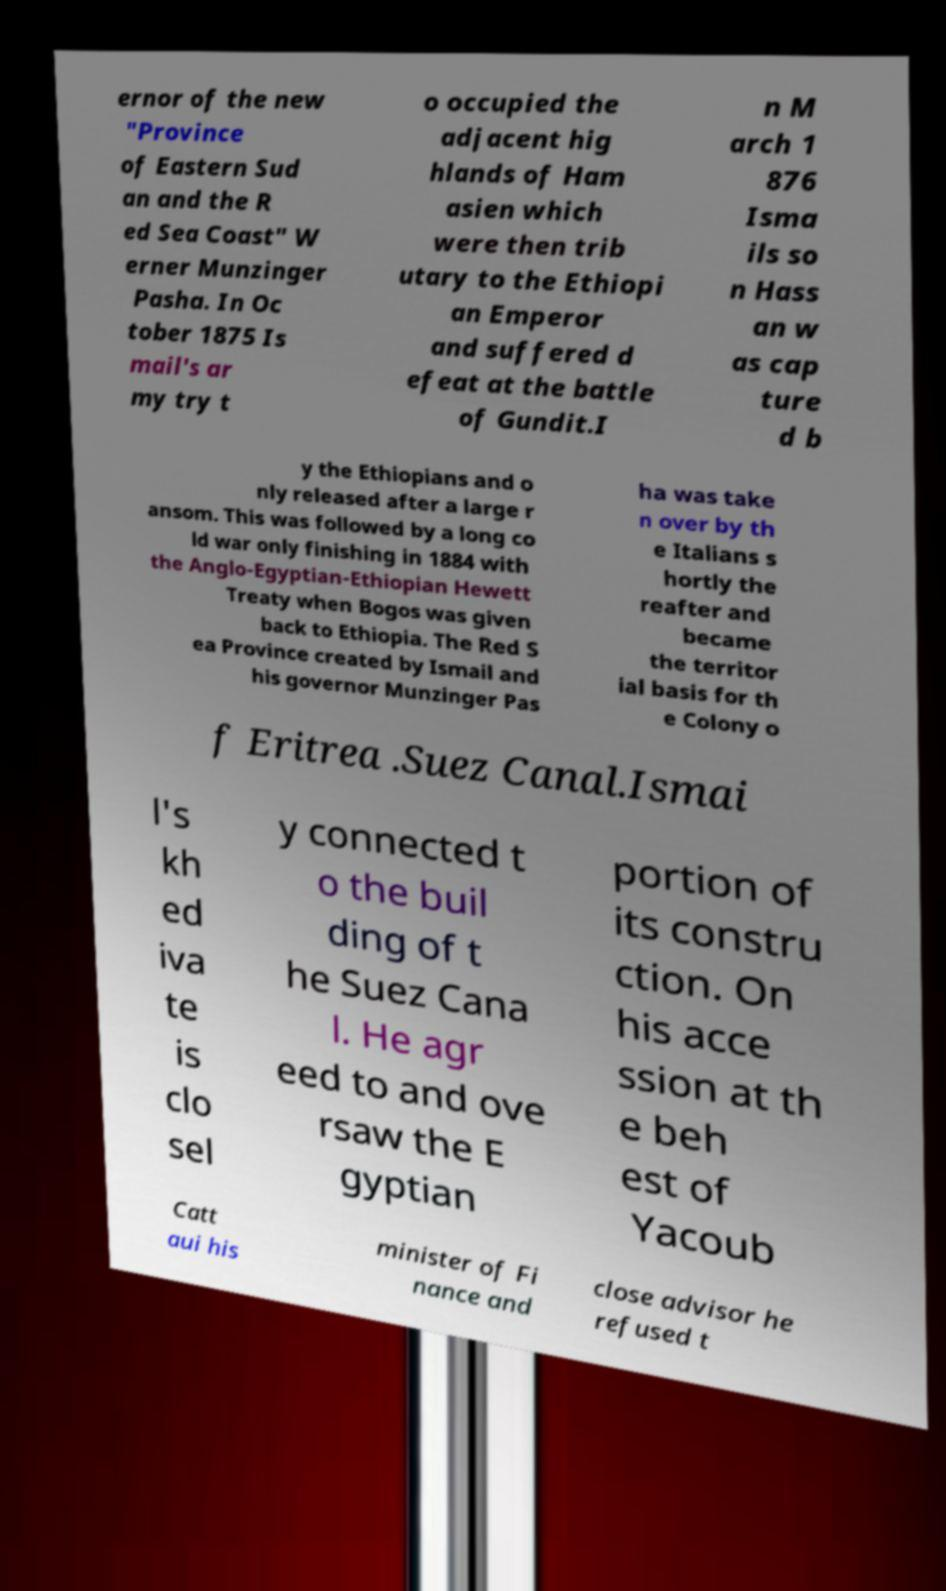For documentation purposes, I need the text within this image transcribed. Could you provide that? ernor of the new "Province of Eastern Sud an and the R ed Sea Coast" W erner Munzinger Pasha. In Oc tober 1875 Is mail's ar my try t o occupied the adjacent hig hlands of Ham asien which were then trib utary to the Ethiopi an Emperor and suffered d efeat at the battle of Gundit.I n M arch 1 876 Isma ils so n Hass an w as cap ture d b y the Ethiopians and o nly released after a large r ansom. This was followed by a long co ld war only finishing in 1884 with the Anglo-Egyptian-Ethiopian Hewett Treaty when Bogos was given back to Ethiopia. The Red S ea Province created by Ismail and his governor Munzinger Pas ha was take n over by th e Italians s hortly the reafter and became the territor ial basis for th e Colony o f Eritrea .Suez Canal.Ismai l's kh ed iva te is clo sel y connected t o the buil ding of t he Suez Cana l. He agr eed to and ove rsaw the E gyptian portion of its constru ction. On his acce ssion at th e beh est of Yacoub Catt aui his minister of Fi nance and close advisor he refused t 